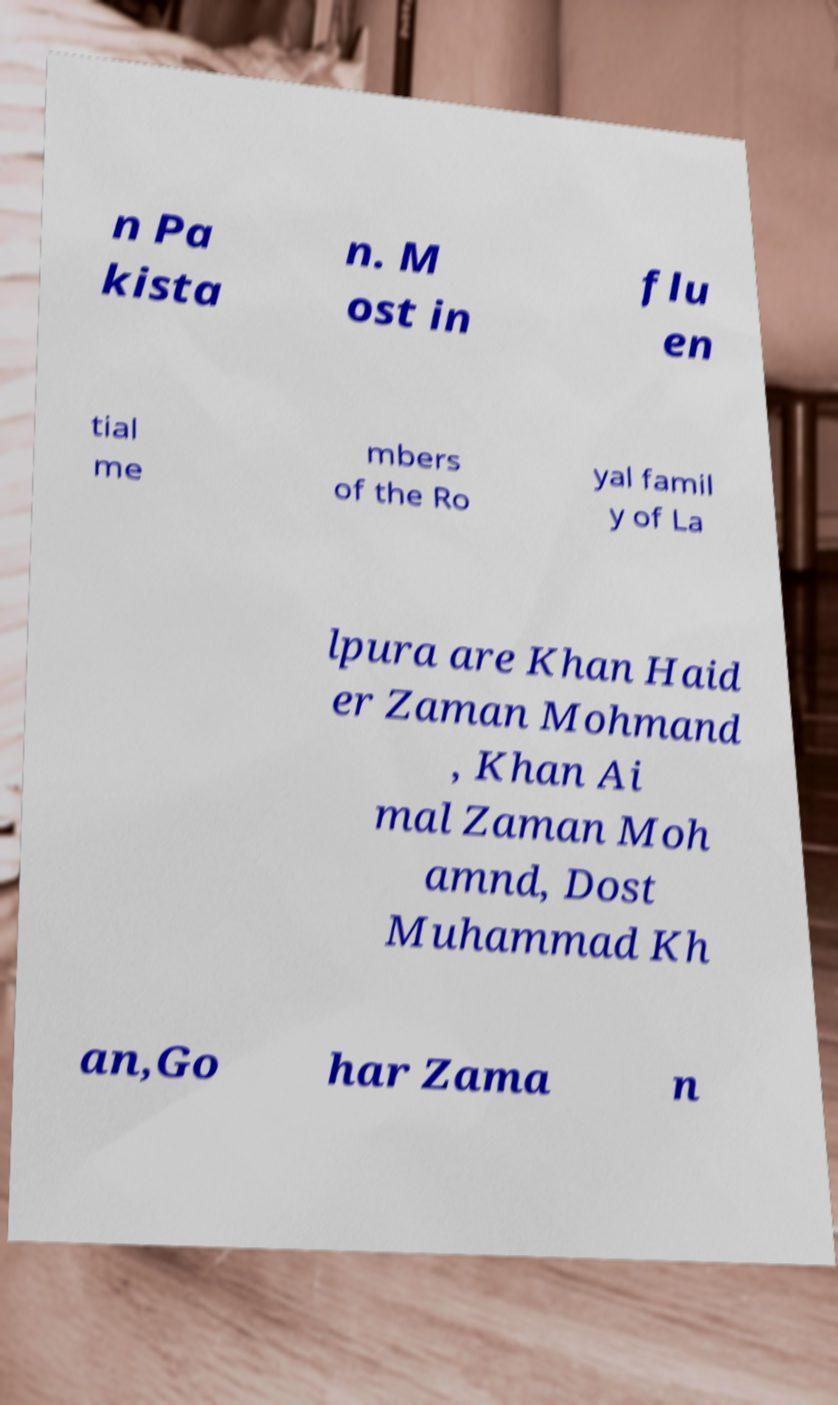I need the written content from this picture converted into text. Can you do that? n Pa kista n. M ost in flu en tial me mbers of the Ro yal famil y of La lpura are Khan Haid er Zaman Mohmand , Khan Ai mal Zaman Moh amnd, Dost Muhammad Kh an,Go har Zama n 